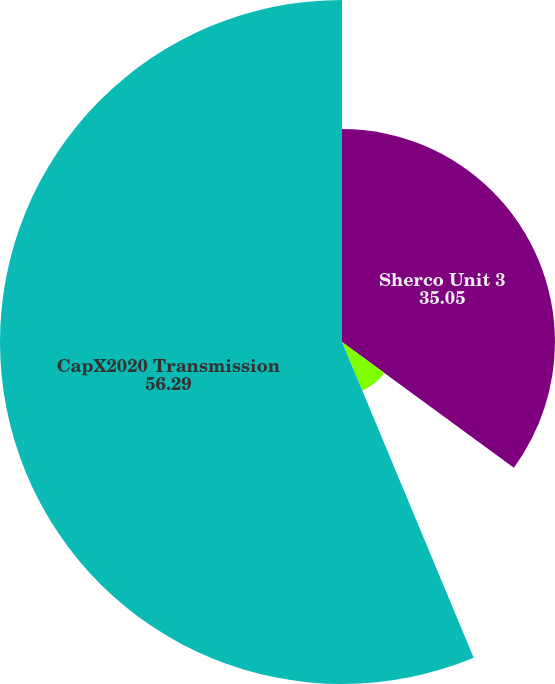Convert chart. <chart><loc_0><loc_0><loc_500><loc_500><pie_chart><fcel>Sherco Unit 3<fcel>Sherco Common Facilities Units<fcel>CapX2020 Transmission<nl><fcel>35.05%<fcel>8.66%<fcel>56.29%<nl></chart> 